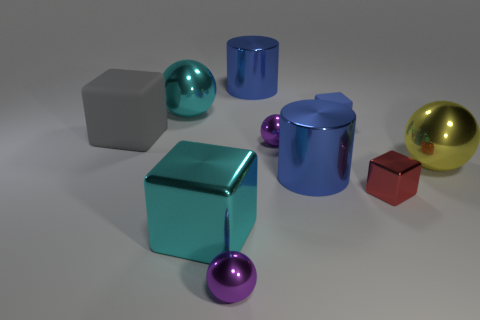Subtract all cylinders. How many objects are left? 8 Subtract all small metal things. Subtract all large blocks. How many objects are left? 5 Add 1 cyan objects. How many cyan objects are left? 3 Add 9 gray rubber blocks. How many gray rubber blocks exist? 10 Subtract 0 cyan cylinders. How many objects are left? 10 